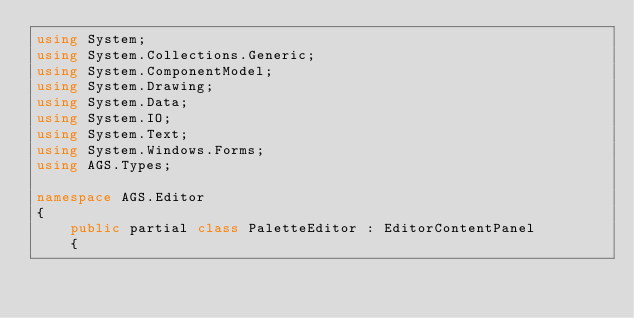<code> <loc_0><loc_0><loc_500><loc_500><_C#_>using System;
using System.Collections.Generic;
using System.ComponentModel;
using System.Drawing;
using System.Data;
using System.IO;
using System.Text;
using System.Windows.Forms;
using AGS.Types;

namespace AGS.Editor
{
    public partial class PaletteEditor : EditorContentPanel
    {</code> 